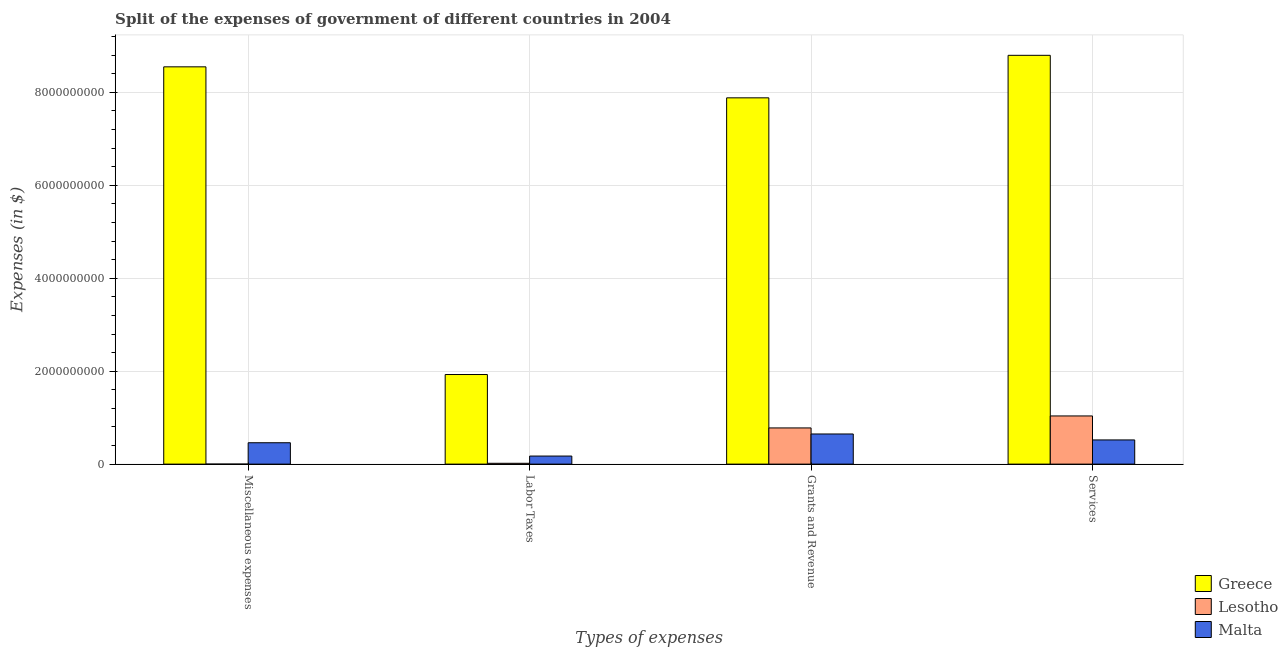How many different coloured bars are there?
Your answer should be compact. 3. Are the number of bars per tick equal to the number of legend labels?
Offer a terse response. Yes. How many bars are there on the 3rd tick from the left?
Your answer should be compact. 3. How many bars are there on the 2nd tick from the right?
Provide a short and direct response. 3. What is the label of the 4th group of bars from the left?
Make the answer very short. Services. What is the amount spent on services in Lesotho?
Make the answer very short. 1.04e+09. Across all countries, what is the maximum amount spent on grants and revenue?
Give a very brief answer. 7.88e+09. In which country was the amount spent on grants and revenue minimum?
Ensure brevity in your answer.  Malta. What is the total amount spent on grants and revenue in the graph?
Provide a short and direct response. 9.31e+09. What is the difference between the amount spent on miscellaneous expenses in Lesotho and that in Greece?
Your answer should be very brief. -8.55e+09. What is the difference between the amount spent on labor taxes in Malta and the amount spent on services in Lesotho?
Give a very brief answer. -8.63e+08. What is the average amount spent on miscellaneous expenses per country?
Offer a terse response. 3.00e+09. What is the difference between the amount spent on services and amount spent on miscellaneous expenses in Lesotho?
Provide a short and direct response. 1.04e+09. In how many countries, is the amount spent on grants and revenue greater than 8400000000 $?
Provide a succinct answer. 0. What is the ratio of the amount spent on miscellaneous expenses in Greece to that in Lesotho?
Ensure brevity in your answer.  8.55e+06. Is the amount spent on miscellaneous expenses in Greece less than that in Malta?
Provide a succinct answer. No. Is the difference between the amount spent on grants and revenue in Lesotho and Malta greater than the difference between the amount spent on miscellaneous expenses in Lesotho and Malta?
Your answer should be compact. Yes. What is the difference between the highest and the second highest amount spent on grants and revenue?
Provide a short and direct response. 7.10e+09. What is the difference between the highest and the lowest amount spent on miscellaneous expenses?
Offer a terse response. 8.55e+09. Is it the case that in every country, the sum of the amount spent on services and amount spent on labor taxes is greater than the sum of amount spent on miscellaneous expenses and amount spent on grants and revenue?
Your answer should be very brief. Yes. What does the 3rd bar from the left in Miscellaneous expenses represents?
Offer a terse response. Malta. What does the 2nd bar from the right in Labor Taxes represents?
Keep it short and to the point. Lesotho. How many bars are there?
Offer a very short reply. 12. Are the values on the major ticks of Y-axis written in scientific E-notation?
Make the answer very short. No. Does the graph contain grids?
Provide a succinct answer. Yes. Where does the legend appear in the graph?
Provide a short and direct response. Bottom right. How are the legend labels stacked?
Your response must be concise. Vertical. What is the title of the graph?
Provide a succinct answer. Split of the expenses of government of different countries in 2004. What is the label or title of the X-axis?
Ensure brevity in your answer.  Types of expenses. What is the label or title of the Y-axis?
Make the answer very short. Expenses (in $). What is the Expenses (in $) of Greece in Miscellaneous expenses?
Your answer should be compact. 8.55e+09. What is the Expenses (in $) of Malta in Miscellaneous expenses?
Offer a terse response. 4.60e+08. What is the Expenses (in $) of Greece in Labor Taxes?
Make the answer very short. 1.93e+09. What is the Expenses (in $) of Lesotho in Labor Taxes?
Your answer should be compact. 1.78e+07. What is the Expenses (in $) in Malta in Labor Taxes?
Your answer should be very brief. 1.73e+08. What is the Expenses (in $) in Greece in Grants and Revenue?
Make the answer very short. 7.88e+09. What is the Expenses (in $) in Lesotho in Grants and Revenue?
Your response must be concise. 7.79e+08. What is the Expenses (in $) of Malta in Grants and Revenue?
Make the answer very short. 6.48e+08. What is the Expenses (in $) in Greece in Services?
Ensure brevity in your answer.  8.80e+09. What is the Expenses (in $) of Lesotho in Services?
Your answer should be compact. 1.04e+09. What is the Expenses (in $) of Malta in Services?
Ensure brevity in your answer.  5.20e+08. Across all Types of expenses, what is the maximum Expenses (in $) of Greece?
Offer a very short reply. 8.80e+09. Across all Types of expenses, what is the maximum Expenses (in $) in Lesotho?
Provide a short and direct response. 1.04e+09. Across all Types of expenses, what is the maximum Expenses (in $) in Malta?
Your answer should be very brief. 6.48e+08. Across all Types of expenses, what is the minimum Expenses (in $) of Greece?
Give a very brief answer. 1.93e+09. Across all Types of expenses, what is the minimum Expenses (in $) of Malta?
Make the answer very short. 1.73e+08. What is the total Expenses (in $) of Greece in the graph?
Make the answer very short. 2.72e+1. What is the total Expenses (in $) in Lesotho in the graph?
Make the answer very short. 1.83e+09. What is the total Expenses (in $) of Malta in the graph?
Provide a succinct answer. 1.80e+09. What is the difference between the Expenses (in $) of Greece in Miscellaneous expenses and that in Labor Taxes?
Make the answer very short. 6.62e+09. What is the difference between the Expenses (in $) of Lesotho in Miscellaneous expenses and that in Labor Taxes?
Keep it short and to the point. -1.78e+07. What is the difference between the Expenses (in $) in Malta in Miscellaneous expenses and that in Labor Taxes?
Offer a terse response. 2.87e+08. What is the difference between the Expenses (in $) in Greece in Miscellaneous expenses and that in Grants and Revenue?
Offer a terse response. 6.67e+08. What is the difference between the Expenses (in $) in Lesotho in Miscellaneous expenses and that in Grants and Revenue?
Ensure brevity in your answer.  -7.79e+08. What is the difference between the Expenses (in $) in Malta in Miscellaneous expenses and that in Grants and Revenue?
Offer a very short reply. -1.88e+08. What is the difference between the Expenses (in $) in Greece in Miscellaneous expenses and that in Services?
Offer a very short reply. -2.48e+08. What is the difference between the Expenses (in $) of Lesotho in Miscellaneous expenses and that in Services?
Give a very brief answer. -1.04e+09. What is the difference between the Expenses (in $) in Malta in Miscellaneous expenses and that in Services?
Your answer should be compact. -6.04e+07. What is the difference between the Expenses (in $) of Greece in Labor Taxes and that in Grants and Revenue?
Provide a succinct answer. -5.96e+09. What is the difference between the Expenses (in $) of Lesotho in Labor Taxes and that in Grants and Revenue?
Offer a very short reply. -7.61e+08. What is the difference between the Expenses (in $) of Malta in Labor Taxes and that in Grants and Revenue?
Offer a terse response. -4.75e+08. What is the difference between the Expenses (in $) of Greece in Labor Taxes and that in Services?
Keep it short and to the point. -6.87e+09. What is the difference between the Expenses (in $) of Lesotho in Labor Taxes and that in Services?
Give a very brief answer. -1.02e+09. What is the difference between the Expenses (in $) of Malta in Labor Taxes and that in Services?
Make the answer very short. -3.47e+08. What is the difference between the Expenses (in $) in Greece in Grants and Revenue and that in Services?
Ensure brevity in your answer.  -9.15e+08. What is the difference between the Expenses (in $) of Lesotho in Grants and Revenue and that in Services?
Make the answer very short. -2.58e+08. What is the difference between the Expenses (in $) in Malta in Grants and Revenue and that in Services?
Offer a terse response. 1.28e+08. What is the difference between the Expenses (in $) of Greece in Miscellaneous expenses and the Expenses (in $) of Lesotho in Labor Taxes?
Provide a short and direct response. 8.53e+09. What is the difference between the Expenses (in $) of Greece in Miscellaneous expenses and the Expenses (in $) of Malta in Labor Taxes?
Your answer should be compact. 8.38e+09. What is the difference between the Expenses (in $) of Lesotho in Miscellaneous expenses and the Expenses (in $) of Malta in Labor Taxes?
Provide a succinct answer. -1.73e+08. What is the difference between the Expenses (in $) of Greece in Miscellaneous expenses and the Expenses (in $) of Lesotho in Grants and Revenue?
Offer a terse response. 7.77e+09. What is the difference between the Expenses (in $) of Greece in Miscellaneous expenses and the Expenses (in $) of Malta in Grants and Revenue?
Your response must be concise. 7.90e+09. What is the difference between the Expenses (in $) in Lesotho in Miscellaneous expenses and the Expenses (in $) in Malta in Grants and Revenue?
Keep it short and to the point. -6.48e+08. What is the difference between the Expenses (in $) in Greece in Miscellaneous expenses and the Expenses (in $) in Lesotho in Services?
Offer a very short reply. 7.51e+09. What is the difference between the Expenses (in $) of Greece in Miscellaneous expenses and the Expenses (in $) of Malta in Services?
Provide a succinct answer. 8.03e+09. What is the difference between the Expenses (in $) in Lesotho in Miscellaneous expenses and the Expenses (in $) in Malta in Services?
Keep it short and to the point. -5.20e+08. What is the difference between the Expenses (in $) in Greece in Labor Taxes and the Expenses (in $) in Lesotho in Grants and Revenue?
Offer a terse response. 1.15e+09. What is the difference between the Expenses (in $) in Greece in Labor Taxes and the Expenses (in $) in Malta in Grants and Revenue?
Provide a short and direct response. 1.28e+09. What is the difference between the Expenses (in $) of Lesotho in Labor Taxes and the Expenses (in $) of Malta in Grants and Revenue?
Give a very brief answer. -6.31e+08. What is the difference between the Expenses (in $) in Greece in Labor Taxes and the Expenses (in $) in Lesotho in Services?
Make the answer very short. 8.91e+08. What is the difference between the Expenses (in $) in Greece in Labor Taxes and the Expenses (in $) in Malta in Services?
Offer a very short reply. 1.41e+09. What is the difference between the Expenses (in $) of Lesotho in Labor Taxes and the Expenses (in $) of Malta in Services?
Provide a short and direct response. -5.03e+08. What is the difference between the Expenses (in $) of Greece in Grants and Revenue and the Expenses (in $) of Lesotho in Services?
Your response must be concise. 6.85e+09. What is the difference between the Expenses (in $) in Greece in Grants and Revenue and the Expenses (in $) in Malta in Services?
Offer a very short reply. 7.36e+09. What is the difference between the Expenses (in $) in Lesotho in Grants and Revenue and the Expenses (in $) in Malta in Services?
Provide a short and direct response. 2.58e+08. What is the average Expenses (in $) in Greece per Types of expenses?
Give a very brief answer. 6.79e+09. What is the average Expenses (in $) of Lesotho per Types of expenses?
Offer a terse response. 4.58e+08. What is the average Expenses (in $) in Malta per Types of expenses?
Provide a short and direct response. 4.51e+08. What is the difference between the Expenses (in $) in Greece and Expenses (in $) in Lesotho in Miscellaneous expenses?
Give a very brief answer. 8.55e+09. What is the difference between the Expenses (in $) in Greece and Expenses (in $) in Malta in Miscellaneous expenses?
Your answer should be very brief. 8.09e+09. What is the difference between the Expenses (in $) in Lesotho and Expenses (in $) in Malta in Miscellaneous expenses?
Provide a short and direct response. -4.60e+08. What is the difference between the Expenses (in $) in Greece and Expenses (in $) in Lesotho in Labor Taxes?
Provide a short and direct response. 1.91e+09. What is the difference between the Expenses (in $) in Greece and Expenses (in $) in Malta in Labor Taxes?
Make the answer very short. 1.75e+09. What is the difference between the Expenses (in $) in Lesotho and Expenses (in $) in Malta in Labor Taxes?
Your answer should be compact. -1.56e+08. What is the difference between the Expenses (in $) in Greece and Expenses (in $) in Lesotho in Grants and Revenue?
Provide a short and direct response. 7.10e+09. What is the difference between the Expenses (in $) of Greece and Expenses (in $) of Malta in Grants and Revenue?
Provide a succinct answer. 7.23e+09. What is the difference between the Expenses (in $) of Lesotho and Expenses (in $) of Malta in Grants and Revenue?
Your answer should be compact. 1.30e+08. What is the difference between the Expenses (in $) in Greece and Expenses (in $) in Lesotho in Services?
Give a very brief answer. 7.76e+09. What is the difference between the Expenses (in $) of Greece and Expenses (in $) of Malta in Services?
Give a very brief answer. 8.28e+09. What is the difference between the Expenses (in $) of Lesotho and Expenses (in $) of Malta in Services?
Keep it short and to the point. 5.16e+08. What is the ratio of the Expenses (in $) of Greece in Miscellaneous expenses to that in Labor Taxes?
Your answer should be very brief. 4.43. What is the ratio of the Expenses (in $) in Malta in Miscellaneous expenses to that in Labor Taxes?
Offer a terse response. 2.65. What is the ratio of the Expenses (in $) of Greece in Miscellaneous expenses to that in Grants and Revenue?
Your response must be concise. 1.08. What is the ratio of the Expenses (in $) of Lesotho in Miscellaneous expenses to that in Grants and Revenue?
Offer a terse response. 0. What is the ratio of the Expenses (in $) of Malta in Miscellaneous expenses to that in Grants and Revenue?
Your response must be concise. 0.71. What is the ratio of the Expenses (in $) in Greece in Miscellaneous expenses to that in Services?
Provide a succinct answer. 0.97. What is the ratio of the Expenses (in $) in Lesotho in Miscellaneous expenses to that in Services?
Your response must be concise. 0. What is the ratio of the Expenses (in $) in Malta in Miscellaneous expenses to that in Services?
Give a very brief answer. 0.88. What is the ratio of the Expenses (in $) of Greece in Labor Taxes to that in Grants and Revenue?
Ensure brevity in your answer.  0.24. What is the ratio of the Expenses (in $) in Lesotho in Labor Taxes to that in Grants and Revenue?
Make the answer very short. 0.02. What is the ratio of the Expenses (in $) in Malta in Labor Taxes to that in Grants and Revenue?
Give a very brief answer. 0.27. What is the ratio of the Expenses (in $) of Greece in Labor Taxes to that in Services?
Ensure brevity in your answer.  0.22. What is the ratio of the Expenses (in $) of Lesotho in Labor Taxes to that in Services?
Give a very brief answer. 0.02. What is the ratio of the Expenses (in $) of Malta in Labor Taxes to that in Services?
Make the answer very short. 0.33. What is the ratio of the Expenses (in $) of Greece in Grants and Revenue to that in Services?
Offer a terse response. 0.9. What is the ratio of the Expenses (in $) in Lesotho in Grants and Revenue to that in Services?
Offer a very short reply. 0.75. What is the ratio of the Expenses (in $) in Malta in Grants and Revenue to that in Services?
Make the answer very short. 1.25. What is the difference between the highest and the second highest Expenses (in $) of Greece?
Provide a succinct answer. 2.48e+08. What is the difference between the highest and the second highest Expenses (in $) of Lesotho?
Provide a succinct answer. 2.58e+08. What is the difference between the highest and the second highest Expenses (in $) of Malta?
Offer a terse response. 1.28e+08. What is the difference between the highest and the lowest Expenses (in $) of Greece?
Your response must be concise. 6.87e+09. What is the difference between the highest and the lowest Expenses (in $) of Lesotho?
Offer a terse response. 1.04e+09. What is the difference between the highest and the lowest Expenses (in $) in Malta?
Give a very brief answer. 4.75e+08. 